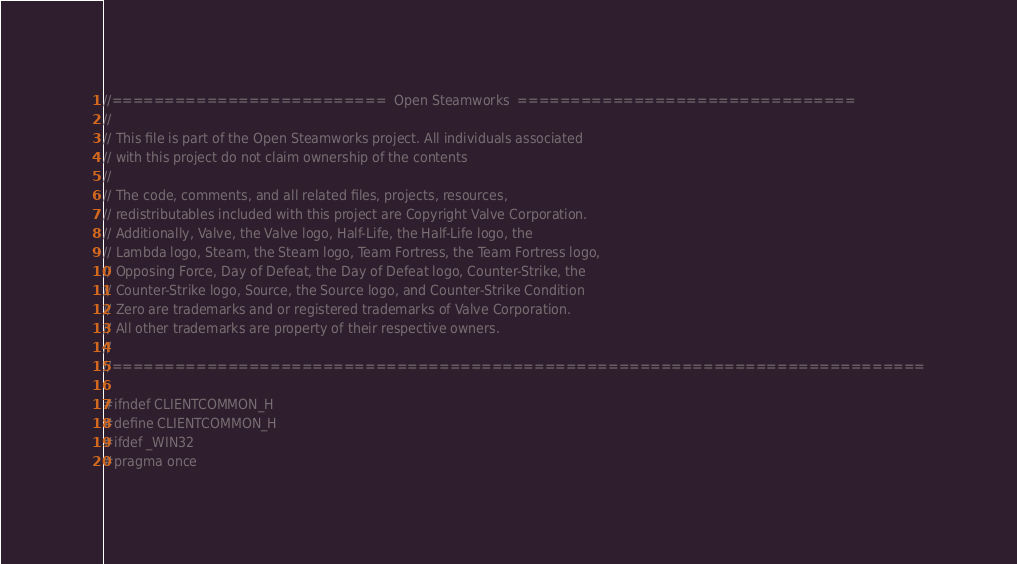<code> <loc_0><loc_0><loc_500><loc_500><_C_>//==========================  Open Steamworks  ================================
//
// This file is part of the Open Steamworks project. All individuals associated
// with this project do not claim ownership of the contents
// 
// The code, comments, and all related files, projects, resources,
// redistributables included with this project are Copyright Valve Corporation.
// Additionally, Valve, the Valve logo, Half-Life, the Half-Life logo, the
// Lambda logo, Steam, the Steam logo, Team Fortress, the Team Fortress logo,
// Opposing Force, Day of Defeat, the Day of Defeat logo, Counter-Strike, the
// Counter-Strike logo, Source, the Source logo, and Counter-Strike Condition
// Zero are trademarks and or registered trademarks of Valve Corporation.
// All other trademarks are property of their respective owners.
//
//=============================================================================

#ifndef CLIENTCOMMON_H
#define CLIENTCOMMON_H
#ifdef _WIN32
#pragma once</code> 